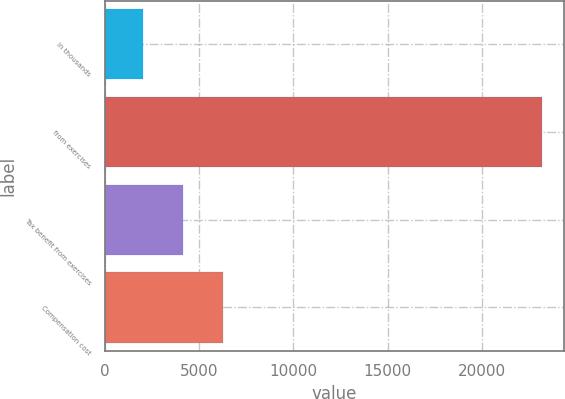Convert chart to OTSL. <chart><loc_0><loc_0><loc_500><loc_500><bar_chart><fcel>in thousands<fcel>from exercises<fcel>Tax benefit from exercises<fcel>Compensation cost<nl><fcel>2014<fcel>23199<fcel>4132.5<fcel>6251<nl></chart> 